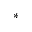<formula> <loc_0><loc_0><loc_500><loc_500>^ { \ast }</formula> 